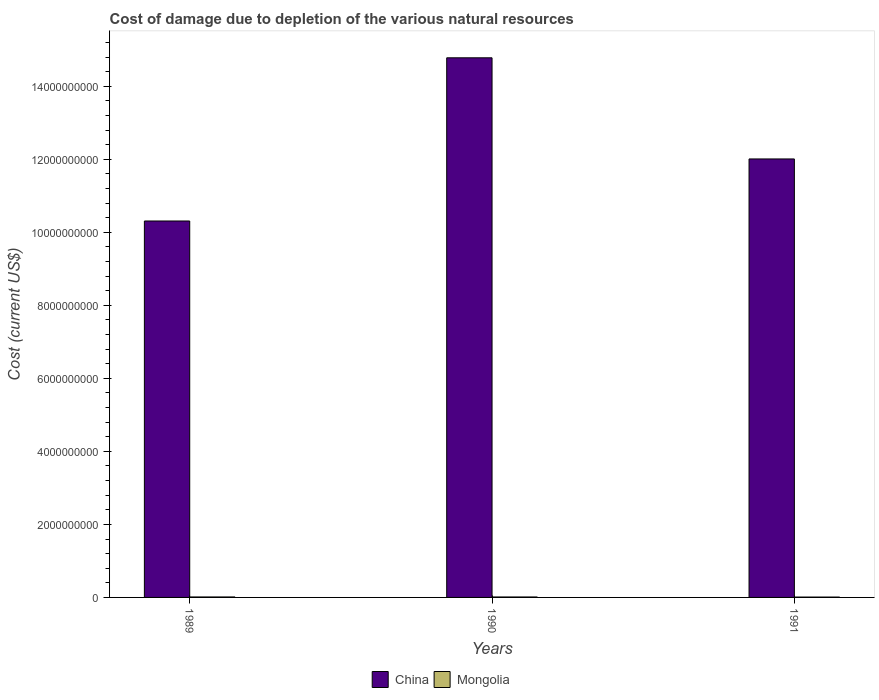Are the number of bars per tick equal to the number of legend labels?
Your response must be concise. Yes. How many bars are there on the 3rd tick from the left?
Your response must be concise. 2. What is the label of the 1st group of bars from the left?
Make the answer very short. 1989. What is the cost of damage caused due to the depletion of various natural resources in China in 1989?
Offer a terse response. 1.03e+1. Across all years, what is the maximum cost of damage caused due to the depletion of various natural resources in Mongolia?
Provide a short and direct response. 1.27e+07. Across all years, what is the minimum cost of damage caused due to the depletion of various natural resources in China?
Make the answer very short. 1.03e+1. In which year was the cost of damage caused due to the depletion of various natural resources in Mongolia minimum?
Your answer should be compact. 1991. What is the total cost of damage caused due to the depletion of various natural resources in Mongolia in the graph?
Your answer should be very brief. 3.47e+07. What is the difference between the cost of damage caused due to the depletion of various natural resources in China in 1989 and that in 1991?
Keep it short and to the point. -1.70e+09. What is the difference between the cost of damage caused due to the depletion of various natural resources in China in 1991 and the cost of damage caused due to the depletion of various natural resources in Mongolia in 1990?
Your answer should be very brief. 1.20e+1. What is the average cost of damage caused due to the depletion of various natural resources in Mongolia per year?
Offer a very short reply. 1.16e+07. In the year 1991, what is the difference between the cost of damage caused due to the depletion of various natural resources in Mongolia and cost of damage caused due to the depletion of various natural resources in China?
Your answer should be compact. -1.20e+1. In how many years, is the cost of damage caused due to the depletion of various natural resources in Mongolia greater than 4400000000 US$?
Your answer should be very brief. 0. What is the ratio of the cost of damage caused due to the depletion of various natural resources in Mongolia in 1990 to that in 1991?
Provide a succinct answer. 1.27. Is the cost of damage caused due to the depletion of various natural resources in Mongolia in 1989 less than that in 1990?
Your response must be concise. No. Is the difference between the cost of damage caused due to the depletion of various natural resources in Mongolia in 1989 and 1990 greater than the difference between the cost of damage caused due to the depletion of various natural resources in China in 1989 and 1990?
Provide a short and direct response. Yes. What is the difference between the highest and the second highest cost of damage caused due to the depletion of various natural resources in Mongolia?
Provide a succinct answer. 3.28e+05. What is the difference between the highest and the lowest cost of damage caused due to the depletion of various natural resources in China?
Provide a short and direct response. 4.47e+09. In how many years, is the cost of damage caused due to the depletion of various natural resources in China greater than the average cost of damage caused due to the depletion of various natural resources in China taken over all years?
Offer a very short reply. 1. What does the 1st bar from the left in 1991 represents?
Offer a terse response. China. What does the 2nd bar from the right in 1991 represents?
Provide a short and direct response. China. What is the difference between two consecutive major ticks on the Y-axis?
Make the answer very short. 2.00e+09. Are the values on the major ticks of Y-axis written in scientific E-notation?
Make the answer very short. No. Does the graph contain grids?
Keep it short and to the point. No. How many legend labels are there?
Provide a succinct answer. 2. What is the title of the graph?
Your answer should be very brief. Cost of damage due to depletion of the various natural resources. What is the label or title of the X-axis?
Your answer should be compact. Years. What is the label or title of the Y-axis?
Keep it short and to the point. Cost (current US$). What is the Cost (current US$) of China in 1989?
Offer a terse response. 1.03e+1. What is the Cost (current US$) in Mongolia in 1989?
Give a very brief answer. 1.27e+07. What is the Cost (current US$) in China in 1990?
Provide a succinct answer. 1.48e+1. What is the Cost (current US$) of Mongolia in 1990?
Offer a very short reply. 1.23e+07. What is the Cost (current US$) in China in 1991?
Make the answer very short. 1.20e+1. What is the Cost (current US$) of Mongolia in 1991?
Offer a terse response. 9.74e+06. Across all years, what is the maximum Cost (current US$) in China?
Give a very brief answer. 1.48e+1. Across all years, what is the maximum Cost (current US$) in Mongolia?
Your answer should be compact. 1.27e+07. Across all years, what is the minimum Cost (current US$) in China?
Make the answer very short. 1.03e+1. Across all years, what is the minimum Cost (current US$) of Mongolia?
Your answer should be compact. 9.74e+06. What is the total Cost (current US$) of China in the graph?
Give a very brief answer. 3.71e+1. What is the total Cost (current US$) of Mongolia in the graph?
Your answer should be compact. 3.47e+07. What is the difference between the Cost (current US$) in China in 1989 and that in 1990?
Keep it short and to the point. -4.47e+09. What is the difference between the Cost (current US$) in Mongolia in 1989 and that in 1990?
Make the answer very short. 3.28e+05. What is the difference between the Cost (current US$) in China in 1989 and that in 1991?
Give a very brief answer. -1.70e+09. What is the difference between the Cost (current US$) of Mongolia in 1989 and that in 1991?
Offer a very short reply. 2.92e+06. What is the difference between the Cost (current US$) of China in 1990 and that in 1991?
Provide a succinct answer. 2.77e+09. What is the difference between the Cost (current US$) of Mongolia in 1990 and that in 1991?
Make the answer very short. 2.59e+06. What is the difference between the Cost (current US$) of China in 1989 and the Cost (current US$) of Mongolia in 1990?
Offer a terse response. 1.03e+1. What is the difference between the Cost (current US$) in China in 1989 and the Cost (current US$) in Mongolia in 1991?
Keep it short and to the point. 1.03e+1. What is the difference between the Cost (current US$) in China in 1990 and the Cost (current US$) in Mongolia in 1991?
Offer a very short reply. 1.48e+1. What is the average Cost (current US$) of China per year?
Offer a terse response. 1.24e+1. What is the average Cost (current US$) of Mongolia per year?
Offer a very short reply. 1.16e+07. In the year 1989, what is the difference between the Cost (current US$) of China and Cost (current US$) of Mongolia?
Offer a terse response. 1.03e+1. In the year 1990, what is the difference between the Cost (current US$) in China and Cost (current US$) in Mongolia?
Offer a very short reply. 1.48e+1. In the year 1991, what is the difference between the Cost (current US$) in China and Cost (current US$) in Mongolia?
Provide a succinct answer. 1.20e+1. What is the ratio of the Cost (current US$) in China in 1989 to that in 1990?
Your response must be concise. 0.7. What is the ratio of the Cost (current US$) in Mongolia in 1989 to that in 1990?
Give a very brief answer. 1.03. What is the ratio of the Cost (current US$) of China in 1989 to that in 1991?
Your answer should be compact. 0.86. What is the ratio of the Cost (current US$) of Mongolia in 1989 to that in 1991?
Your answer should be compact. 1.3. What is the ratio of the Cost (current US$) of China in 1990 to that in 1991?
Provide a succinct answer. 1.23. What is the ratio of the Cost (current US$) in Mongolia in 1990 to that in 1991?
Offer a very short reply. 1.27. What is the difference between the highest and the second highest Cost (current US$) of China?
Your answer should be very brief. 2.77e+09. What is the difference between the highest and the second highest Cost (current US$) in Mongolia?
Give a very brief answer. 3.28e+05. What is the difference between the highest and the lowest Cost (current US$) in China?
Provide a short and direct response. 4.47e+09. What is the difference between the highest and the lowest Cost (current US$) of Mongolia?
Your answer should be compact. 2.92e+06. 